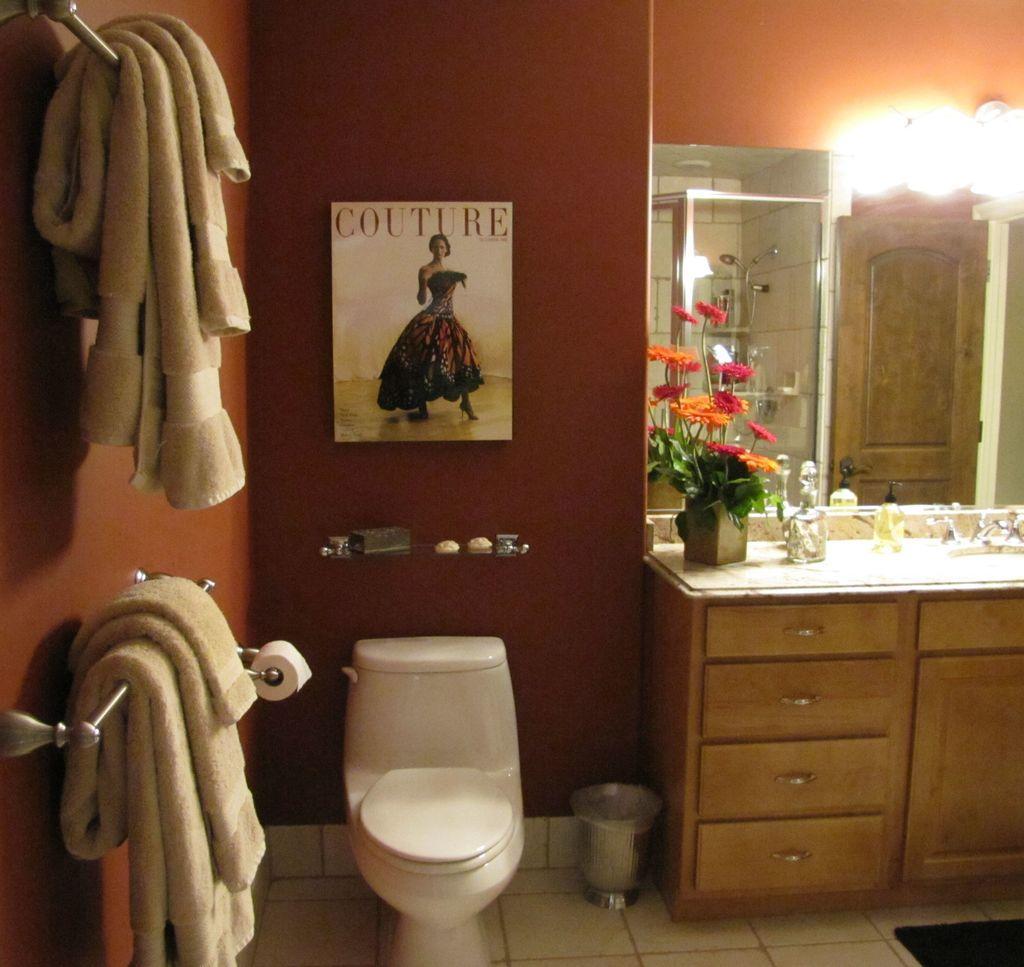Can you describe this image briefly? In this picture we can see towels on hangers, poster on the wall, toilet seat, flush tank, dustbin, tissue paper roll, tap, cupboards, mirror, lights. 